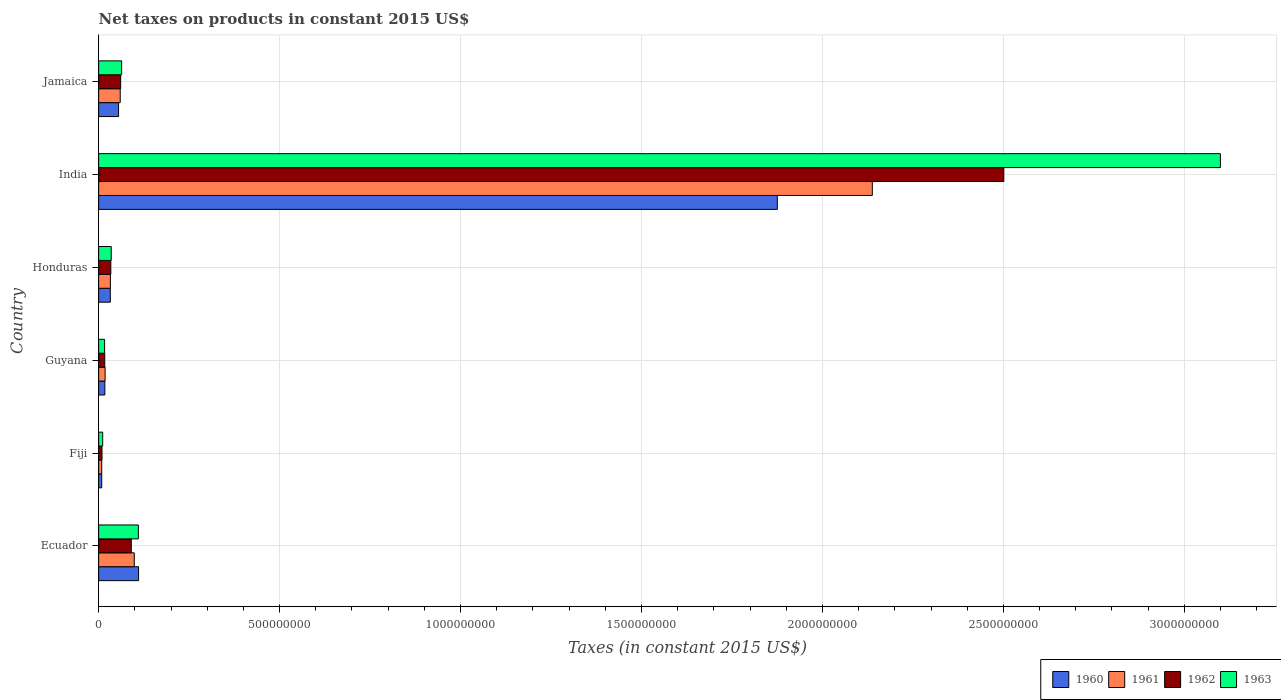Are the number of bars on each tick of the Y-axis equal?
Make the answer very short. Yes. How many bars are there on the 6th tick from the top?
Offer a terse response. 4. In how many cases, is the number of bars for a given country not equal to the number of legend labels?
Give a very brief answer. 0. What is the net taxes on products in 1962 in Guyana?
Provide a short and direct response. 1.69e+07. Across all countries, what is the maximum net taxes on products in 1962?
Offer a very short reply. 2.50e+09. Across all countries, what is the minimum net taxes on products in 1963?
Give a very brief answer. 1.12e+07. In which country was the net taxes on products in 1963 minimum?
Provide a succinct answer. Fiji. What is the total net taxes on products in 1960 in the graph?
Provide a short and direct response. 2.10e+09. What is the difference between the net taxes on products in 1963 in Fiji and that in India?
Your answer should be very brief. -3.09e+09. What is the difference between the net taxes on products in 1961 in Jamaica and the net taxes on products in 1963 in India?
Provide a short and direct response. -3.04e+09. What is the average net taxes on products in 1960 per country?
Your answer should be very brief. 3.50e+08. What is the difference between the net taxes on products in 1962 and net taxes on products in 1963 in India?
Your answer should be compact. -5.99e+08. What is the ratio of the net taxes on products in 1963 in Ecuador to that in Fiji?
Offer a terse response. 9.79. What is the difference between the highest and the second highest net taxes on products in 1960?
Your response must be concise. 1.76e+09. What is the difference between the highest and the lowest net taxes on products in 1961?
Your response must be concise. 2.13e+09. In how many countries, is the net taxes on products in 1961 greater than the average net taxes on products in 1961 taken over all countries?
Provide a short and direct response. 1. Is the sum of the net taxes on products in 1962 in Guyana and Jamaica greater than the maximum net taxes on products in 1961 across all countries?
Your response must be concise. No. Is it the case that in every country, the sum of the net taxes on products in 1962 and net taxes on products in 1963 is greater than the sum of net taxes on products in 1960 and net taxes on products in 1961?
Ensure brevity in your answer.  No. What does the 4th bar from the top in Honduras represents?
Keep it short and to the point. 1960. Is it the case that in every country, the sum of the net taxes on products in 1960 and net taxes on products in 1963 is greater than the net taxes on products in 1962?
Provide a succinct answer. Yes. How many bars are there?
Keep it short and to the point. 24. Are all the bars in the graph horizontal?
Make the answer very short. Yes. What is the difference between two consecutive major ticks on the X-axis?
Keep it short and to the point. 5.00e+08. Does the graph contain any zero values?
Ensure brevity in your answer.  No. How are the legend labels stacked?
Provide a short and direct response. Horizontal. What is the title of the graph?
Give a very brief answer. Net taxes on products in constant 2015 US$. Does "1997" appear as one of the legend labels in the graph?
Offer a very short reply. No. What is the label or title of the X-axis?
Your response must be concise. Taxes (in constant 2015 US$). What is the Taxes (in constant 2015 US$) of 1960 in Ecuador?
Provide a succinct answer. 1.10e+08. What is the Taxes (in constant 2015 US$) in 1961 in Ecuador?
Your answer should be very brief. 9.85e+07. What is the Taxes (in constant 2015 US$) in 1962 in Ecuador?
Offer a terse response. 9.03e+07. What is the Taxes (in constant 2015 US$) in 1963 in Ecuador?
Keep it short and to the point. 1.10e+08. What is the Taxes (in constant 2015 US$) of 1960 in Fiji?
Keep it short and to the point. 8.56e+06. What is the Taxes (in constant 2015 US$) of 1961 in Fiji?
Give a very brief answer. 8.56e+06. What is the Taxes (in constant 2015 US$) of 1962 in Fiji?
Offer a terse response. 9.32e+06. What is the Taxes (in constant 2015 US$) of 1963 in Fiji?
Provide a succinct answer. 1.12e+07. What is the Taxes (in constant 2015 US$) in 1960 in Guyana?
Your response must be concise. 1.71e+07. What is the Taxes (in constant 2015 US$) of 1961 in Guyana?
Offer a terse response. 1.79e+07. What is the Taxes (in constant 2015 US$) in 1962 in Guyana?
Provide a short and direct response. 1.69e+07. What is the Taxes (in constant 2015 US$) in 1963 in Guyana?
Your answer should be very brief. 1.64e+07. What is the Taxes (in constant 2015 US$) in 1960 in Honduras?
Provide a short and direct response. 3.22e+07. What is the Taxes (in constant 2015 US$) of 1961 in Honduras?
Make the answer very short. 3.25e+07. What is the Taxes (in constant 2015 US$) of 1962 in Honduras?
Your answer should be compact. 3.36e+07. What is the Taxes (in constant 2015 US$) of 1963 in Honduras?
Your answer should be compact. 3.48e+07. What is the Taxes (in constant 2015 US$) in 1960 in India?
Provide a short and direct response. 1.88e+09. What is the Taxes (in constant 2015 US$) of 1961 in India?
Your answer should be very brief. 2.14e+09. What is the Taxes (in constant 2015 US$) in 1962 in India?
Provide a succinct answer. 2.50e+09. What is the Taxes (in constant 2015 US$) of 1963 in India?
Offer a very short reply. 3.10e+09. What is the Taxes (in constant 2015 US$) of 1960 in Jamaica?
Offer a terse response. 5.50e+07. What is the Taxes (in constant 2015 US$) of 1961 in Jamaica?
Offer a terse response. 5.96e+07. What is the Taxes (in constant 2015 US$) of 1962 in Jamaica?
Offer a terse response. 6.09e+07. What is the Taxes (in constant 2015 US$) of 1963 in Jamaica?
Offer a very short reply. 6.36e+07. Across all countries, what is the maximum Taxes (in constant 2015 US$) of 1960?
Make the answer very short. 1.88e+09. Across all countries, what is the maximum Taxes (in constant 2015 US$) of 1961?
Your answer should be very brief. 2.14e+09. Across all countries, what is the maximum Taxes (in constant 2015 US$) in 1962?
Provide a short and direct response. 2.50e+09. Across all countries, what is the maximum Taxes (in constant 2015 US$) in 1963?
Offer a terse response. 3.10e+09. Across all countries, what is the minimum Taxes (in constant 2015 US$) of 1960?
Offer a very short reply. 8.56e+06. Across all countries, what is the minimum Taxes (in constant 2015 US$) of 1961?
Keep it short and to the point. 8.56e+06. Across all countries, what is the minimum Taxes (in constant 2015 US$) in 1962?
Provide a short and direct response. 9.32e+06. Across all countries, what is the minimum Taxes (in constant 2015 US$) in 1963?
Provide a succinct answer. 1.12e+07. What is the total Taxes (in constant 2015 US$) of 1960 in the graph?
Keep it short and to the point. 2.10e+09. What is the total Taxes (in constant 2015 US$) of 1961 in the graph?
Ensure brevity in your answer.  2.35e+09. What is the total Taxes (in constant 2015 US$) of 1962 in the graph?
Your answer should be very brief. 2.71e+09. What is the total Taxes (in constant 2015 US$) of 1963 in the graph?
Keep it short and to the point. 3.34e+09. What is the difference between the Taxes (in constant 2015 US$) of 1960 in Ecuador and that in Fiji?
Offer a terse response. 1.02e+08. What is the difference between the Taxes (in constant 2015 US$) of 1961 in Ecuador and that in Fiji?
Your answer should be very brief. 8.99e+07. What is the difference between the Taxes (in constant 2015 US$) in 1962 in Ecuador and that in Fiji?
Your response must be concise. 8.09e+07. What is the difference between the Taxes (in constant 2015 US$) in 1963 in Ecuador and that in Fiji?
Your answer should be compact. 9.86e+07. What is the difference between the Taxes (in constant 2015 US$) of 1960 in Ecuador and that in Guyana?
Offer a very short reply. 9.32e+07. What is the difference between the Taxes (in constant 2015 US$) in 1961 in Ecuador and that in Guyana?
Your answer should be compact. 8.06e+07. What is the difference between the Taxes (in constant 2015 US$) in 1962 in Ecuador and that in Guyana?
Make the answer very short. 7.33e+07. What is the difference between the Taxes (in constant 2015 US$) of 1963 in Ecuador and that in Guyana?
Give a very brief answer. 9.33e+07. What is the difference between the Taxes (in constant 2015 US$) of 1960 in Ecuador and that in Honduras?
Provide a short and direct response. 7.81e+07. What is the difference between the Taxes (in constant 2015 US$) in 1961 in Ecuador and that in Honduras?
Offer a very short reply. 6.60e+07. What is the difference between the Taxes (in constant 2015 US$) in 1962 in Ecuador and that in Honduras?
Offer a terse response. 5.66e+07. What is the difference between the Taxes (in constant 2015 US$) in 1963 in Ecuador and that in Honduras?
Provide a succinct answer. 7.50e+07. What is the difference between the Taxes (in constant 2015 US$) in 1960 in Ecuador and that in India?
Make the answer very short. -1.76e+09. What is the difference between the Taxes (in constant 2015 US$) in 1961 in Ecuador and that in India?
Make the answer very short. -2.04e+09. What is the difference between the Taxes (in constant 2015 US$) in 1962 in Ecuador and that in India?
Make the answer very short. -2.41e+09. What is the difference between the Taxes (in constant 2015 US$) in 1963 in Ecuador and that in India?
Your answer should be compact. -2.99e+09. What is the difference between the Taxes (in constant 2015 US$) in 1960 in Ecuador and that in Jamaica?
Offer a terse response. 5.53e+07. What is the difference between the Taxes (in constant 2015 US$) in 1961 in Ecuador and that in Jamaica?
Provide a short and direct response. 3.88e+07. What is the difference between the Taxes (in constant 2015 US$) in 1962 in Ecuador and that in Jamaica?
Your response must be concise. 2.94e+07. What is the difference between the Taxes (in constant 2015 US$) of 1963 in Ecuador and that in Jamaica?
Keep it short and to the point. 4.62e+07. What is the difference between the Taxes (in constant 2015 US$) in 1960 in Fiji and that in Guyana?
Give a very brief answer. -8.59e+06. What is the difference between the Taxes (in constant 2015 US$) of 1961 in Fiji and that in Guyana?
Ensure brevity in your answer.  -9.34e+06. What is the difference between the Taxes (in constant 2015 US$) in 1962 in Fiji and that in Guyana?
Your response must be concise. -7.60e+06. What is the difference between the Taxes (in constant 2015 US$) of 1963 in Fiji and that in Guyana?
Provide a short and direct response. -5.24e+06. What is the difference between the Taxes (in constant 2015 US$) of 1960 in Fiji and that in Honduras?
Provide a succinct answer. -2.37e+07. What is the difference between the Taxes (in constant 2015 US$) of 1961 in Fiji and that in Honduras?
Offer a very short reply. -2.39e+07. What is the difference between the Taxes (in constant 2015 US$) of 1962 in Fiji and that in Honduras?
Your response must be concise. -2.43e+07. What is the difference between the Taxes (in constant 2015 US$) of 1963 in Fiji and that in Honduras?
Your answer should be very brief. -2.36e+07. What is the difference between the Taxes (in constant 2015 US$) in 1960 in Fiji and that in India?
Your answer should be compact. -1.87e+09. What is the difference between the Taxes (in constant 2015 US$) of 1961 in Fiji and that in India?
Offer a very short reply. -2.13e+09. What is the difference between the Taxes (in constant 2015 US$) of 1962 in Fiji and that in India?
Ensure brevity in your answer.  -2.49e+09. What is the difference between the Taxes (in constant 2015 US$) in 1963 in Fiji and that in India?
Provide a short and direct response. -3.09e+09. What is the difference between the Taxes (in constant 2015 US$) in 1960 in Fiji and that in Jamaica?
Provide a short and direct response. -4.65e+07. What is the difference between the Taxes (in constant 2015 US$) of 1961 in Fiji and that in Jamaica?
Your response must be concise. -5.11e+07. What is the difference between the Taxes (in constant 2015 US$) of 1962 in Fiji and that in Jamaica?
Offer a very short reply. -5.16e+07. What is the difference between the Taxes (in constant 2015 US$) in 1963 in Fiji and that in Jamaica?
Give a very brief answer. -5.24e+07. What is the difference between the Taxes (in constant 2015 US$) of 1960 in Guyana and that in Honduras?
Provide a succinct answer. -1.51e+07. What is the difference between the Taxes (in constant 2015 US$) of 1961 in Guyana and that in Honduras?
Give a very brief answer. -1.46e+07. What is the difference between the Taxes (in constant 2015 US$) in 1962 in Guyana and that in Honduras?
Your answer should be very brief. -1.67e+07. What is the difference between the Taxes (in constant 2015 US$) in 1963 in Guyana and that in Honduras?
Your response must be concise. -1.84e+07. What is the difference between the Taxes (in constant 2015 US$) in 1960 in Guyana and that in India?
Your response must be concise. -1.86e+09. What is the difference between the Taxes (in constant 2015 US$) in 1961 in Guyana and that in India?
Provide a short and direct response. -2.12e+09. What is the difference between the Taxes (in constant 2015 US$) in 1962 in Guyana and that in India?
Your response must be concise. -2.48e+09. What is the difference between the Taxes (in constant 2015 US$) of 1963 in Guyana and that in India?
Provide a short and direct response. -3.08e+09. What is the difference between the Taxes (in constant 2015 US$) in 1960 in Guyana and that in Jamaica?
Your response must be concise. -3.79e+07. What is the difference between the Taxes (in constant 2015 US$) in 1961 in Guyana and that in Jamaica?
Keep it short and to the point. -4.17e+07. What is the difference between the Taxes (in constant 2015 US$) in 1962 in Guyana and that in Jamaica?
Provide a succinct answer. -4.40e+07. What is the difference between the Taxes (in constant 2015 US$) of 1963 in Guyana and that in Jamaica?
Your response must be concise. -4.71e+07. What is the difference between the Taxes (in constant 2015 US$) in 1960 in Honduras and that in India?
Your answer should be compact. -1.84e+09. What is the difference between the Taxes (in constant 2015 US$) of 1961 in Honduras and that in India?
Provide a short and direct response. -2.11e+09. What is the difference between the Taxes (in constant 2015 US$) of 1962 in Honduras and that in India?
Your answer should be very brief. -2.47e+09. What is the difference between the Taxes (in constant 2015 US$) in 1963 in Honduras and that in India?
Offer a terse response. -3.06e+09. What is the difference between the Taxes (in constant 2015 US$) of 1960 in Honduras and that in Jamaica?
Make the answer very short. -2.28e+07. What is the difference between the Taxes (in constant 2015 US$) in 1961 in Honduras and that in Jamaica?
Your answer should be very brief. -2.71e+07. What is the difference between the Taxes (in constant 2015 US$) of 1962 in Honduras and that in Jamaica?
Keep it short and to the point. -2.72e+07. What is the difference between the Taxes (in constant 2015 US$) in 1963 in Honduras and that in Jamaica?
Your response must be concise. -2.88e+07. What is the difference between the Taxes (in constant 2015 US$) of 1960 in India and that in Jamaica?
Offer a terse response. 1.82e+09. What is the difference between the Taxes (in constant 2015 US$) of 1961 in India and that in Jamaica?
Ensure brevity in your answer.  2.08e+09. What is the difference between the Taxes (in constant 2015 US$) in 1962 in India and that in Jamaica?
Offer a terse response. 2.44e+09. What is the difference between the Taxes (in constant 2015 US$) in 1963 in India and that in Jamaica?
Provide a short and direct response. 3.04e+09. What is the difference between the Taxes (in constant 2015 US$) in 1960 in Ecuador and the Taxes (in constant 2015 US$) in 1961 in Fiji?
Provide a short and direct response. 1.02e+08. What is the difference between the Taxes (in constant 2015 US$) in 1960 in Ecuador and the Taxes (in constant 2015 US$) in 1962 in Fiji?
Your answer should be very brief. 1.01e+08. What is the difference between the Taxes (in constant 2015 US$) in 1960 in Ecuador and the Taxes (in constant 2015 US$) in 1963 in Fiji?
Your response must be concise. 9.91e+07. What is the difference between the Taxes (in constant 2015 US$) of 1961 in Ecuador and the Taxes (in constant 2015 US$) of 1962 in Fiji?
Ensure brevity in your answer.  8.91e+07. What is the difference between the Taxes (in constant 2015 US$) in 1961 in Ecuador and the Taxes (in constant 2015 US$) in 1963 in Fiji?
Your answer should be very brief. 8.73e+07. What is the difference between the Taxes (in constant 2015 US$) of 1962 in Ecuador and the Taxes (in constant 2015 US$) of 1963 in Fiji?
Your answer should be compact. 7.91e+07. What is the difference between the Taxes (in constant 2015 US$) of 1960 in Ecuador and the Taxes (in constant 2015 US$) of 1961 in Guyana?
Offer a terse response. 9.24e+07. What is the difference between the Taxes (in constant 2015 US$) of 1960 in Ecuador and the Taxes (in constant 2015 US$) of 1962 in Guyana?
Provide a succinct answer. 9.34e+07. What is the difference between the Taxes (in constant 2015 US$) of 1960 in Ecuador and the Taxes (in constant 2015 US$) of 1963 in Guyana?
Give a very brief answer. 9.39e+07. What is the difference between the Taxes (in constant 2015 US$) of 1961 in Ecuador and the Taxes (in constant 2015 US$) of 1962 in Guyana?
Give a very brief answer. 8.16e+07. What is the difference between the Taxes (in constant 2015 US$) of 1961 in Ecuador and the Taxes (in constant 2015 US$) of 1963 in Guyana?
Offer a very short reply. 8.20e+07. What is the difference between the Taxes (in constant 2015 US$) in 1962 in Ecuador and the Taxes (in constant 2015 US$) in 1963 in Guyana?
Your answer should be very brief. 7.38e+07. What is the difference between the Taxes (in constant 2015 US$) in 1960 in Ecuador and the Taxes (in constant 2015 US$) in 1961 in Honduras?
Offer a very short reply. 7.78e+07. What is the difference between the Taxes (in constant 2015 US$) in 1960 in Ecuador and the Taxes (in constant 2015 US$) in 1962 in Honduras?
Offer a very short reply. 7.67e+07. What is the difference between the Taxes (in constant 2015 US$) of 1960 in Ecuador and the Taxes (in constant 2015 US$) of 1963 in Honduras?
Provide a short and direct response. 7.55e+07. What is the difference between the Taxes (in constant 2015 US$) in 1961 in Ecuador and the Taxes (in constant 2015 US$) in 1962 in Honduras?
Offer a terse response. 6.48e+07. What is the difference between the Taxes (in constant 2015 US$) of 1961 in Ecuador and the Taxes (in constant 2015 US$) of 1963 in Honduras?
Provide a succinct answer. 6.37e+07. What is the difference between the Taxes (in constant 2015 US$) in 1962 in Ecuador and the Taxes (in constant 2015 US$) in 1963 in Honduras?
Offer a very short reply. 5.55e+07. What is the difference between the Taxes (in constant 2015 US$) in 1960 in Ecuador and the Taxes (in constant 2015 US$) in 1961 in India?
Your response must be concise. -2.03e+09. What is the difference between the Taxes (in constant 2015 US$) of 1960 in Ecuador and the Taxes (in constant 2015 US$) of 1962 in India?
Give a very brief answer. -2.39e+09. What is the difference between the Taxes (in constant 2015 US$) of 1960 in Ecuador and the Taxes (in constant 2015 US$) of 1963 in India?
Your answer should be compact. -2.99e+09. What is the difference between the Taxes (in constant 2015 US$) in 1961 in Ecuador and the Taxes (in constant 2015 US$) in 1962 in India?
Make the answer very short. -2.40e+09. What is the difference between the Taxes (in constant 2015 US$) in 1961 in Ecuador and the Taxes (in constant 2015 US$) in 1963 in India?
Keep it short and to the point. -3.00e+09. What is the difference between the Taxes (in constant 2015 US$) in 1962 in Ecuador and the Taxes (in constant 2015 US$) in 1963 in India?
Give a very brief answer. -3.01e+09. What is the difference between the Taxes (in constant 2015 US$) of 1960 in Ecuador and the Taxes (in constant 2015 US$) of 1961 in Jamaica?
Offer a very short reply. 5.07e+07. What is the difference between the Taxes (in constant 2015 US$) of 1960 in Ecuador and the Taxes (in constant 2015 US$) of 1962 in Jamaica?
Make the answer very short. 4.94e+07. What is the difference between the Taxes (in constant 2015 US$) in 1960 in Ecuador and the Taxes (in constant 2015 US$) in 1963 in Jamaica?
Give a very brief answer. 4.68e+07. What is the difference between the Taxes (in constant 2015 US$) in 1961 in Ecuador and the Taxes (in constant 2015 US$) in 1962 in Jamaica?
Provide a succinct answer. 3.76e+07. What is the difference between the Taxes (in constant 2015 US$) of 1961 in Ecuador and the Taxes (in constant 2015 US$) of 1963 in Jamaica?
Your answer should be compact. 3.49e+07. What is the difference between the Taxes (in constant 2015 US$) in 1962 in Ecuador and the Taxes (in constant 2015 US$) in 1963 in Jamaica?
Your response must be concise. 2.67e+07. What is the difference between the Taxes (in constant 2015 US$) of 1960 in Fiji and the Taxes (in constant 2015 US$) of 1961 in Guyana?
Offer a terse response. -9.34e+06. What is the difference between the Taxes (in constant 2015 US$) in 1960 in Fiji and the Taxes (in constant 2015 US$) in 1962 in Guyana?
Your answer should be compact. -8.35e+06. What is the difference between the Taxes (in constant 2015 US$) of 1960 in Fiji and the Taxes (in constant 2015 US$) of 1963 in Guyana?
Offer a terse response. -7.89e+06. What is the difference between the Taxes (in constant 2015 US$) of 1961 in Fiji and the Taxes (in constant 2015 US$) of 1962 in Guyana?
Offer a very short reply. -8.35e+06. What is the difference between the Taxes (in constant 2015 US$) in 1961 in Fiji and the Taxes (in constant 2015 US$) in 1963 in Guyana?
Offer a very short reply. -7.89e+06. What is the difference between the Taxes (in constant 2015 US$) of 1962 in Fiji and the Taxes (in constant 2015 US$) of 1963 in Guyana?
Your answer should be very brief. -7.13e+06. What is the difference between the Taxes (in constant 2015 US$) in 1960 in Fiji and the Taxes (in constant 2015 US$) in 1961 in Honduras?
Offer a very short reply. -2.39e+07. What is the difference between the Taxes (in constant 2015 US$) of 1960 in Fiji and the Taxes (in constant 2015 US$) of 1962 in Honduras?
Make the answer very short. -2.51e+07. What is the difference between the Taxes (in constant 2015 US$) of 1960 in Fiji and the Taxes (in constant 2015 US$) of 1963 in Honduras?
Your response must be concise. -2.62e+07. What is the difference between the Taxes (in constant 2015 US$) in 1961 in Fiji and the Taxes (in constant 2015 US$) in 1962 in Honduras?
Offer a terse response. -2.51e+07. What is the difference between the Taxes (in constant 2015 US$) of 1961 in Fiji and the Taxes (in constant 2015 US$) of 1963 in Honduras?
Keep it short and to the point. -2.62e+07. What is the difference between the Taxes (in constant 2015 US$) in 1962 in Fiji and the Taxes (in constant 2015 US$) in 1963 in Honduras?
Make the answer very short. -2.55e+07. What is the difference between the Taxes (in constant 2015 US$) of 1960 in Fiji and the Taxes (in constant 2015 US$) of 1961 in India?
Provide a short and direct response. -2.13e+09. What is the difference between the Taxes (in constant 2015 US$) of 1960 in Fiji and the Taxes (in constant 2015 US$) of 1962 in India?
Your answer should be compact. -2.49e+09. What is the difference between the Taxes (in constant 2015 US$) in 1960 in Fiji and the Taxes (in constant 2015 US$) in 1963 in India?
Provide a short and direct response. -3.09e+09. What is the difference between the Taxes (in constant 2015 US$) in 1961 in Fiji and the Taxes (in constant 2015 US$) in 1962 in India?
Your response must be concise. -2.49e+09. What is the difference between the Taxes (in constant 2015 US$) of 1961 in Fiji and the Taxes (in constant 2015 US$) of 1963 in India?
Provide a succinct answer. -3.09e+09. What is the difference between the Taxes (in constant 2015 US$) of 1962 in Fiji and the Taxes (in constant 2015 US$) of 1963 in India?
Your answer should be compact. -3.09e+09. What is the difference between the Taxes (in constant 2015 US$) in 1960 in Fiji and the Taxes (in constant 2015 US$) in 1961 in Jamaica?
Your answer should be very brief. -5.11e+07. What is the difference between the Taxes (in constant 2015 US$) of 1960 in Fiji and the Taxes (in constant 2015 US$) of 1962 in Jamaica?
Give a very brief answer. -5.23e+07. What is the difference between the Taxes (in constant 2015 US$) in 1960 in Fiji and the Taxes (in constant 2015 US$) in 1963 in Jamaica?
Offer a terse response. -5.50e+07. What is the difference between the Taxes (in constant 2015 US$) in 1961 in Fiji and the Taxes (in constant 2015 US$) in 1962 in Jamaica?
Your answer should be compact. -5.23e+07. What is the difference between the Taxes (in constant 2015 US$) of 1961 in Fiji and the Taxes (in constant 2015 US$) of 1963 in Jamaica?
Your answer should be compact. -5.50e+07. What is the difference between the Taxes (in constant 2015 US$) of 1962 in Fiji and the Taxes (in constant 2015 US$) of 1963 in Jamaica?
Your response must be concise. -5.42e+07. What is the difference between the Taxes (in constant 2015 US$) of 1960 in Guyana and the Taxes (in constant 2015 US$) of 1961 in Honduras?
Your response must be concise. -1.54e+07. What is the difference between the Taxes (in constant 2015 US$) in 1960 in Guyana and the Taxes (in constant 2015 US$) in 1962 in Honduras?
Provide a short and direct response. -1.65e+07. What is the difference between the Taxes (in constant 2015 US$) in 1960 in Guyana and the Taxes (in constant 2015 US$) in 1963 in Honduras?
Provide a succinct answer. -1.77e+07. What is the difference between the Taxes (in constant 2015 US$) of 1961 in Guyana and the Taxes (in constant 2015 US$) of 1962 in Honduras?
Your answer should be very brief. -1.57e+07. What is the difference between the Taxes (in constant 2015 US$) in 1961 in Guyana and the Taxes (in constant 2015 US$) in 1963 in Honduras?
Your answer should be compact. -1.69e+07. What is the difference between the Taxes (in constant 2015 US$) in 1962 in Guyana and the Taxes (in constant 2015 US$) in 1963 in Honduras?
Your response must be concise. -1.79e+07. What is the difference between the Taxes (in constant 2015 US$) of 1960 in Guyana and the Taxes (in constant 2015 US$) of 1961 in India?
Offer a terse response. -2.12e+09. What is the difference between the Taxes (in constant 2015 US$) of 1960 in Guyana and the Taxes (in constant 2015 US$) of 1962 in India?
Offer a terse response. -2.48e+09. What is the difference between the Taxes (in constant 2015 US$) of 1960 in Guyana and the Taxes (in constant 2015 US$) of 1963 in India?
Give a very brief answer. -3.08e+09. What is the difference between the Taxes (in constant 2015 US$) of 1961 in Guyana and the Taxes (in constant 2015 US$) of 1962 in India?
Give a very brief answer. -2.48e+09. What is the difference between the Taxes (in constant 2015 US$) of 1961 in Guyana and the Taxes (in constant 2015 US$) of 1963 in India?
Give a very brief answer. -3.08e+09. What is the difference between the Taxes (in constant 2015 US$) in 1962 in Guyana and the Taxes (in constant 2015 US$) in 1963 in India?
Your answer should be compact. -3.08e+09. What is the difference between the Taxes (in constant 2015 US$) of 1960 in Guyana and the Taxes (in constant 2015 US$) of 1961 in Jamaica?
Ensure brevity in your answer.  -4.25e+07. What is the difference between the Taxes (in constant 2015 US$) of 1960 in Guyana and the Taxes (in constant 2015 US$) of 1962 in Jamaica?
Your answer should be compact. -4.38e+07. What is the difference between the Taxes (in constant 2015 US$) in 1960 in Guyana and the Taxes (in constant 2015 US$) in 1963 in Jamaica?
Keep it short and to the point. -4.64e+07. What is the difference between the Taxes (in constant 2015 US$) of 1961 in Guyana and the Taxes (in constant 2015 US$) of 1962 in Jamaica?
Provide a succinct answer. -4.30e+07. What is the difference between the Taxes (in constant 2015 US$) of 1961 in Guyana and the Taxes (in constant 2015 US$) of 1963 in Jamaica?
Offer a terse response. -4.57e+07. What is the difference between the Taxes (in constant 2015 US$) in 1962 in Guyana and the Taxes (in constant 2015 US$) in 1963 in Jamaica?
Provide a short and direct response. -4.66e+07. What is the difference between the Taxes (in constant 2015 US$) of 1960 in Honduras and the Taxes (in constant 2015 US$) of 1961 in India?
Provide a succinct answer. -2.11e+09. What is the difference between the Taxes (in constant 2015 US$) in 1960 in Honduras and the Taxes (in constant 2015 US$) in 1962 in India?
Offer a very short reply. -2.47e+09. What is the difference between the Taxes (in constant 2015 US$) of 1960 in Honduras and the Taxes (in constant 2015 US$) of 1963 in India?
Offer a terse response. -3.07e+09. What is the difference between the Taxes (in constant 2015 US$) in 1961 in Honduras and the Taxes (in constant 2015 US$) in 1962 in India?
Make the answer very short. -2.47e+09. What is the difference between the Taxes (in constant 2015 US$) of 1961 in Honduras and the Taxes (in constant 2015 US$) of 1963 in India?
Your response must be concise. -3.07e+09. What is the difference between the Taxes (in constant 2015 US$) in 1962 in Honduras and the Taxes (in constant 2015 US$) in 1963 in India?
Make the answer very short. -3.07e+09. What is the difference between the Taxes (in constant 2015 US$) in 1960 in Honduras and the Taxes (in constant 2015 US$) in 1961 in Jamaica?
Your answer should be compact. -2.74e+07. What is the difference between the Taxes (in constant 2015 US$) in 1960 in Honduras and the Taxes (in constant 2015 US$) in 1962 in Jamaica?
Provide a succinct answer. -2.86e+07. What is the difference between the Taxes (in constant 2015 US$) in 1960 in Honduras and the Taxes (in constant 2015 US$) in 1963 in Jamaica?
Your response must be concise. -3.13e+07. What is the difference between the Taxes (in constant 2015 US$) of 1961 in Honduras and the Taxes (in constant 2015 US$) of 1962 in Jamaica?
Ensure brevity in your answer.  -2.84e+07. What is the difference between the Taxes (in constant 2015 US$) of 1961 in Honduras and the Taxes (in constant 2015 US$) of 1963 in Jamaica?
Ensure brevity in your answer.  -3.11e+07. What is the difference between the Taxes (in constant 2015 US$) of 1962 in Honduras and the Taxes (in constant 2015 US$) of 1963 in Jamaica?
Make the answer very short. -2.99e+07. What is the difference between the Taxes (in constant 2015 US$) in 1960 in India and the Taxes (in constant 2015 US$) in 1961 in Jamaica?
Offer a terse response. 1.82e+09. What is the difference between the Taxes (in constant 2015 US$) of 1960 in India and the Taxes (in constant 2015 US$) of 1962 in Jamaica?
Give a very brief answer. 1.81e+09. What is the difference between the Taxes (in constant 2015 US$) in 1960 in India and the Taxes (in constant 2015 US$) in 1963 in Jamaica?
Offer a terse response. 1.81e+09. What is the difference between the Taxes (in constant 2015 US$) of 1961 in India and the Taxes (in constant 2015 US$) of 1962 in Jamaica?
Your answer should be very brief. 2.08e+09. What is the difference between the Taxes (in constant 2015 US$) in 1961 in India and the Taxes (in constant 2015 US$) in 1963 in Jamaica?
Offer a very short reply. 2.07e+09. What is the difference between the Taxes (in constant 2015 US$) in 1962 in India and the Taxes (in constant 2015 US$) in 1963 in Jamaica?
Your response must be concise. 2.44e+09. What is the average Taxes (in constant 2015 US$) of 1960 per country?
Make the answer very short. 3.50e+08. What is the average Taxes (in constant 2015 US$) in 1961 per country?
Offer a very short reply. 3.92e+08. What is the average Taxes (in constant 2015 US$) in 1962 per country?
Your answer should be very brief. 4.52e+08. What is the average Taxes (in constant 2015 US$) of 1963 per country?
Keep it short and to the point. 5.56e+08. What is the difference between the Taxes (in constant 2015 US$) in 1960 and Taxes (in constant 2015 US$) in 1961 in Ecuador?
Provide a short and direct response. 1.19e+07. What is the difference between the Taxes (in constant 2015 US$) in 1960 and Taxes (in constant 2015 US$) in 1962 in Ecuador?
Your answer should be very brief. 2.01e+07. What is the difference between the Taxes (in constant 2015 US$) in 1960 and Taxes (in constant 2015 US$) in 1963 in Ecuador?
Provide a short and direct response. 5.57e+05. What is the difference between the Taxes (in constant 2015 US$) in 1961 and Taxes (in constant 2015 US$) in 1962 in Ecuador?
Your answer should be compact. 8.21e+06. What is the difference between the Taxes (in constant 2015 US$) in 1961 and Taxes (in constant 2015 US$) in 1963 in Ecuador?
Your answer should be compact. -1.13e+07. What is the difference between the Taxes (in constant 2015 US$) in 1962 and Taxes (in constant 2015 US$) in 1963 in Ecuador?
Ensure brevity in your answer.  -1.95e+07. What is the difference between the Taxes (in constant 2015 US$) in 1960 and Taxes (in constant 2015 US$) in 1961 in Fiji?
Offer a terse response. 0. What is the difference between the Taxes (in constant 2015 US$) of 1960 and Taxes (in constant 2015 US$) of 1962 in Fiji?
Your response must be concise. -7.56e+05. What is the difference between the Taxes (in constant 2015 US$) in 1960 and Taxes (in constant 2015 US$) in 1963 in Fiji?
Ensure brevity in your answer.  -2.64e+06. What is the difference between the Taxes (in constant 2015 US$) in 1961 and Taxes (in constant 2015 US$) in 1962 in Fiji?
Ensure brevity in your answer.  -7.56e+05. What is the difference between the Taxes (in constant 2015 US$) of 1961 and Taxes (in constant 2015 US$) of 1963 in Fiji?
Make the answer very short. -2.64e+06. What is the difference between the Taxes (in constant 2015 US$) in 1962 and Taxes (in constant 2015 US$) in 1963 in Fiji?
Your answer should be very brief. -1.89e+06. What is the difference between the Taxes (in constant 2015 US$) in 1960 and Taxes (in constant 2015 US$) in 1961 in Guyana?
Keep it short and to the point. -7.58e+05. What is the difference between the Taxes (in constant 2015 US$) of 1960 and Taxes (in constant 2015 US$) of 1962 in Guyana?
Make the answer very short. 2.33e+05. What is the difference between the Taxes (in constant 2015 US$) of 1960 and Taxes (in constant 2015 US$) of 1963 in Guyana?
Provide a succinct answer. 7.00e+05. What is the difference between the Taxes (in constant 2015 US$) of 1961 and Taxes (in constant 2015 US$) of 1962 in Guyana?
Your answer should be compact. 9.92e+05. What is the difference between the Taxes (in constant 2015 US$) in 1961 and Taxes (in constant 2015 US$) in 1963 in Guyana?
Your answer should be compact. 1.46e+06. What is the difference between the Taxes (in constant 2015 US$) in 1962 and Taxes (in constant 2015 US$) in 1963 in Guyana?
Ensure brevity in your answer.  4.67e+05. What is the difference between the Taxes (in constant 2015 US$) of 1960 and Taxes (in constant 2015 US$) of 1962 in Honduras?
Your answer should be very brief. -1.40e+06. What is the difference between the Taxes (in constant 2015 US$) of 1960 and Taxes (in constant 2015 US$) of 1963 in Honduras?
Your answer should be compact. -2.55e+06. What is the difference between the Taxes (in constant 2015 US$) in 1961 and Taxes (in constant 2015 US$) in 1962 in Honduras?
Your response must be concise. -1.15e+06. What is the difference between the Taxes (in constant 2015 US$) of 1961 and Taxes (in constant 2015 US$) of 1963 in Honduras?
Your answer should be very brief. -2.30e+06. What is the difference between the Taxes (in constant 2015 US$) in 1962 and Taxes (in constant 2015 US$) in 1963 in Honduras?
Your response must be concise. -1.15e+06. What is the difference between the Taxes (in constant 2015 US$) of 1960 and Taxes (in constant 2015 US$) of 1961 in India?
Give a very brief answer. -2.63e+08. What is the difference between the Taxes (in constant 2015 US$) in 1960 and Taxes (in constant 2015 US$) in 1962 in India?
Your answer should be very brief. -6.26e+08. What is the difference between the Taxes (in constant 2015 US$) in 1960 and Taxes (in constant 2015 US$) in 1963 in India?
Your answer should be compact. -1.22e+09. What is the difference between the Taxes (in constant 2015 US$) in 1961 and Taxes (in constant 2015 US$) in 1962 in India?
Your answer should be very brief. -3.63e+08. What is the difference between the Taxes (in constant 2015 US$) of 1961 and Taxes (in constant 2015 US$) of 1963 in India?
Ensure brevity in your answer.  -9.62e+08. What is the difference between the Taxes (in constant 2015 US$) of 1962 and Taxes (in constant 2015 US$) of 1963 in India?
Provide a succinct answer. -5.99e+08. What is the difference between the Taxes (in constant 2015 US$) of 1960 and Taxes (in constant 2015 US$) of 1961 in Jamaica?
Provide a short and direct response. -4.62e+06. What is the difference between the Taxes (in constant 2015 US$) in 1960 and Taxes (in constant 2015 US$) in 1962 in Jamaica?
Keep it short and to the point. -5.88e+06. What is the difference between the Taxes (in constant 2015 US$) in 1960 and Taxes (in constant 2015 US$) in 1963 in Jamaica?
Give a very brief answer. -8.54e+06. What is the difference between the Taxes (in constant 2015 US$) of 1961 and Taxes (in constant 2015 US$) of 1962 in Jamaica?
Keep it short and to the point. -1.26e+06. What is the difference between the Taxes (in constant 2015 US$) in 1961 and Taxes (in constant 2015 US$) in 1963 in Jamaica?
Give a very brief answer. -3.92e+06. What is the difference between the Taxes (in constant 2015 US$) of 1962 and Taxes (in constant 2015 US$) of 1963 in Jamaica?
Your response must be concise. -2.66e+06. What is the ratio of the Taxes (in constant 2015 US$) in 1960 in Ecuador to that in Fiji?
Provide a succinct answer. 12.88. What is the ratio of the Taxes (in constant 2015 US$) in 1961 in Ecuador to that in Fiji?
Make the answer very short. 11.5. What is the ratio of the Taxes (in constant 2015 US$) in 1962 in Ecuador to that in Fiji?
Provide a succinct answer. 9.69. What is the ratio of the Taxes (in constant 2015 US$) of 1963 in Ecuador to that in Fiji?
Make the answer very short. 9.79. What is the ratio of the Taxes (in constant 2015 US$) in 1960 in Ecuador to that in Guyana?
Provide a succinct answer. 6.43. What is the ratio of the Taxes (in constant 2015 US$) of 1961 in Ecuador to that in Guyana?
Give a very brief answer. 5.5. What is the ratio of the Taxes (in constant 2015 US$) of 1962 in Ecuador to that in Guyana?
Your answer should be compact. 5.34. What is the ratio of the Taxes (in constant 2015 US$) in 1963 in Ecuador to that in Guyana?
Offer a very short reply. 6.67. What is the ratio of the Taxes (in constant 2015 US$) in 1960 in Ecuador to that in Honduras?
Ensure brevity in your answer.  3.42. What is the ratio of the Taxes (in constant 2015 US$) of 1961 in Ecuador to that in Honduras?
Give a very brief answer. 3.03. What is the ratio of the Taxes (in constant 2015 US$) in 1962 in Ecuador to that in Honduras?
Make the answer very short. 2.68. What is the ratio of the Taxes (in constant 2015 US$) of 1963 in Ecuador to that in Honduras?
Ensure brevity in your answer.  3.15. What is the ratio of the Taxes (in constant 2015 US$) in 1960 in Ecuador to that in India?
Your response must be concise. 0.06. What is the ratio of the Taxes (in constant 2015 US$) in 1961 in Ecuador to that in India?
Provide a succinct answer. 0.05. What is the ratio of the Taxes (in constant 2015 US$) of 1962 in Ecuador to that in India?
Ensure brevity in your answer.  0.04. What is the ratio of the Taxes (in constant 2015 US$) of 1963 in Ecuador to that in India?
Ensure brevity in your answer.  0.04. What is the ratio of the Taxes (in constant 2015 US$) of 1960 in Ecuador to that in Jamaica?
Your answer should be compact. 2.01. What is the ratio of the Taxes (in constant 2015 US$) of 1961 in Ecuador to that in Jamaica?
Provide a short and direct response. 1.65. What is the ratio of the Taxes (in constant 2015 US$) of 1962 in Ecuador to that in Jamaica?
Give a very brief answer. 1.48. What is the ratio of the Taxes (in constant 2015 US$) of 1963 in Ecuador to that in Jamaica?
Your answer should be very brief. 1.73. What is the ratio of the Taxes (in constant 2015 US$) of 1960 in Fiji to that in Guyana?
Provide a succinct answer. 0.5. What is the ratio of the Taxes (in constant 2015 US$) of 1961 in Fiji to that in Guyana?
Provide a short and direct response. 0.48. What is the ratio of the Taxes (in constant 2015 US$) of 1962 in Fiji to that in Guyana?
Your response must be concise. 0.55. What is the ratio of the Taxes (in constant 2015 US$) of 1963 in Fiji to that in Guyana?
Offer a very short reply. 0.68. What is the ratio of the Taxes (in constant 2015 US$) in 1960 in Fiji to that in Honduras?
Offer a very short reply. 0.27. What is the ratio of the Taxes (in constant 2015 US$) in 1961 in Fiji to that in Honduras?
Provide a short and direct response. 0.26. What is the ratio of the Taxes (in constant 2015 US$) of 1962 in Fiji to that in Honduras?
Offer a very short reply. 0.28. What is the ratio of the Taxes (in constant 2015 US$) of 1963 in Fiji to that in Honduras?
Give a very brief answer. 0.32. What is the ratio of the Taxes (in constant 2015 US$) in 1960 in Fiji to that in India?
Offer a very short reply. 0. What is the ratio of the Taxes (in constant 2015 US$) in 1961 in Fiji to that in India?
Keep it short and to the point. 0. What is the ratio of the Taxes (in constant 2015 US$) of 1962 in Fiji to that in India?
Give a very brief answer. 0. What is the ratio of the Taxes (in constant 2015 US$) of 1963 in Fiji to that in India?
Make the answer very short. 0. What is the ratio of the Taxes (in constant 2015 US$) of 1960 in Fiji to that in Jamaica?
Make the answer very short. 0.16. What is the ratio of the Taxes (in constant 2015 US$) in 1961 in Fiji to that in Jamaica?
Ensure brevity in your answer.  0.14. What is the ratio of the Taxes (in constant 2015 US$) in 1962 in Fiji to that in Jamaica?
Provide a succinct answer. 0.15. What is the ratio of the Taxes (in constant 2015 US$) in 1963 in Fiji to that in Jamaica?
Your response must be concise. 0.18. What is the ratio of the Taxes (in constant 2015 US$) of 1960 in Guyana to that in Honduras?
Ensure brevity in your answer.  0.53. What is the ratio of the Taxes (in constant 2015 US$) in 1961 in Guyana to that in Honduras?
Offer a very short reply. 0.55. What is the ratio of the Taxes (in constant 2015 US$) of 1962 in Guyana to that in Honduras?
Provide a short and direct response. 0.5. What is the ratio of the Taxes (in constant 2015 US$) of 1963 in Guyana to that in Honduras?
Your response must be concise. 0.47. What is the ratio of the Taxes (in constant 2015 US$) of 1960 in Guyana to that in India?
Provide a succinct answer. 0.01. What is the ratio of the Taxes (in constant 2015 US$) of 1961 in Guyana to that in India?
Give a very brief answer. 0.01. What is the ratio of the Taxes (in constant 2015 US$) in 1962 in Guyana to that in India?
Keep it short and to the point. 0.01. What is the ratio of the Taxes (in constant 2015 US$) in 1963 in Guyana to that in India?
Your answer should be compact. 0.01. What is the ratio of the Taxes (in constant 2015 US$) in 1960 in Guyana to that in Jamaica?
Provide a short and direct response. 0.31. What is the ratio of the Taxes (in constant 2015 US$) of 1961 in Guyana to that in Jamaica?
Give a very brief answer. 0.3. What is the ratio of the Taxes (in constant 2015 US$) of 1962 in Guyana to that in Jamaica?
Your answer should be compact. 0.28. What is the ratio of the Taxes (in constant 2015 US$) in 1963 in Guyana to that in Jamaica?
Provide a succinct answer. 0.26. What is the ratio of the Taxes (in constant 2015 US$) in 1960 in Honduras to that in India?
Your response must be concise. 0.02. What is the ratio of the Taxes (in constant 2015 US$) of 1961 in Honduras to that in India?
Your answer should be compact. 0.02. What is the ratio of the Taxes (in constant 2015 US$) in 1962 in Honduras to that in India?
Provide a short and direct response. 0.01. What is the ratio of the Taxes (in constant 2015 US$) of 1963 in Honduras to that in India?
Make the answer very short. 0.01. What is the ratio of the Taxes (in constant 2015 US$) of 1960 in Honduras to that in Jamaica?
Offer a terse response. 0.59. What is the ratio of the Taxes (in constant 2015 US$) in 1961 in Honduras to that in Jamaica?
Offer a very short reply. 0.54. What is the ratio of the Taxes (in constant 2015 US$) in 1962 in Honduras to that in Jamaica?
Keep it short and to the point. 0.55. What is the ratio of the Taxes (in constant 2015 US$) of 1963 in Honduras to that in Jamaica?
Your response must be concise. 0.55. What is the ratio of the Taxes (in constant 2015 US$) in 1960 in India to that in Jamaica?
Keep it short and to the point. 34.08. What is the ratio of the Taxes (in constant 2015 US$) of 1961 in India to that in Jamaica?
Offer a very short reply. 35.85. What is the ratio of the Taxes (in constant 2015 US$) of 1962 in India to that in Jamaica?
Your answer should be very brief. 41.07. What is the ratio of the Taxes (in constant 2015 US$) of 1963 in India to that in Jamaica?
Keep it short and to the point. 48.77. What is the difference between the highest and the second highest Taxes (in constant 2015 US$) of 1960?
Your answer should be very brief. 1.76e+09. What is the difference between the highest and the second highest Taxes (in constant 2015 US$) in 1961?
Keep it short and to the point. 2.04e+09. What is the difference between the highest and the second highest Taxes (in constant 2015 US$) of 1962?
Give a very brief answer. 2.41e+09. What is the difference between the highest and the second highest Taxes (in constant 2015 US$) of 1963?
Offer a terse response. 2.99e+09. What is the difference between the highest and the lowest Taxes (in constant 2015 US$) in 1960?
Provide a short and direct response. 1.87e+09. What is the difference between the highest and the lowest Taxes (in constant 2015 US$) in 1961?
Your answer should be very brief. 2.13e+09. What is the difference between the highest and the lowest Taxes (in constant 2015 US$) of 1962?
Ensure brevity in your answer.  2.49e+09. What is the difference between the highest and the lowest Taxes (in constant 2015 US$) in 1963?
Your response must be concise. 3.09e+09. 